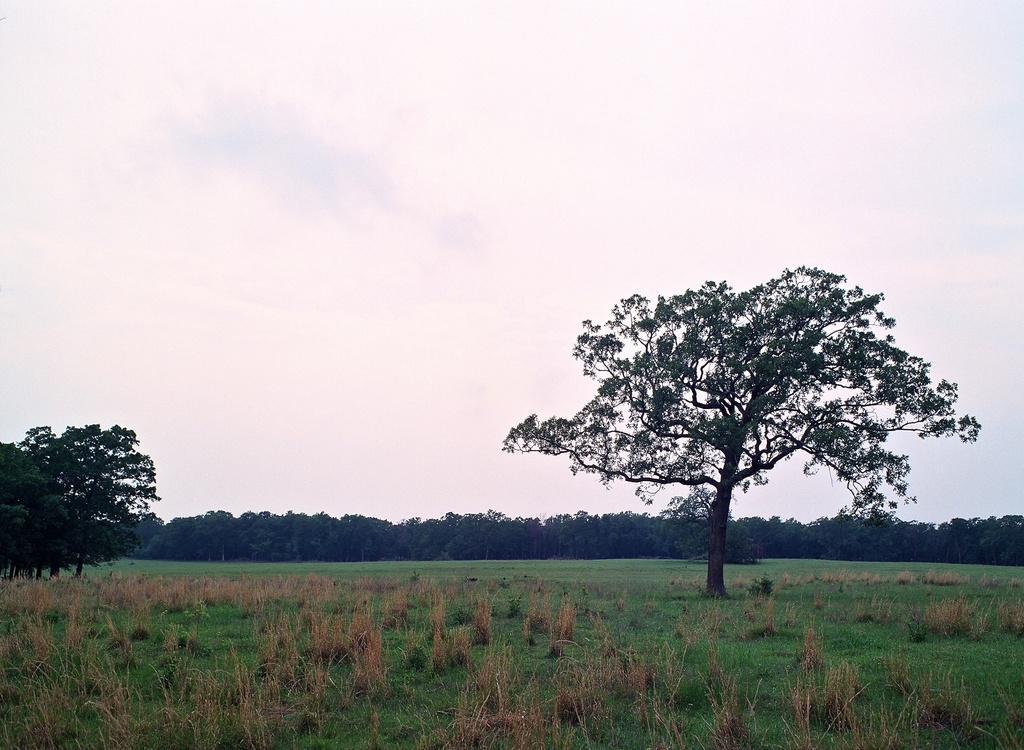In one or two sentences, can you explain what this image depicts? In this picture there are trees. At the top there is sky and there are clouds. At the bottom there is grass and there are plants. 